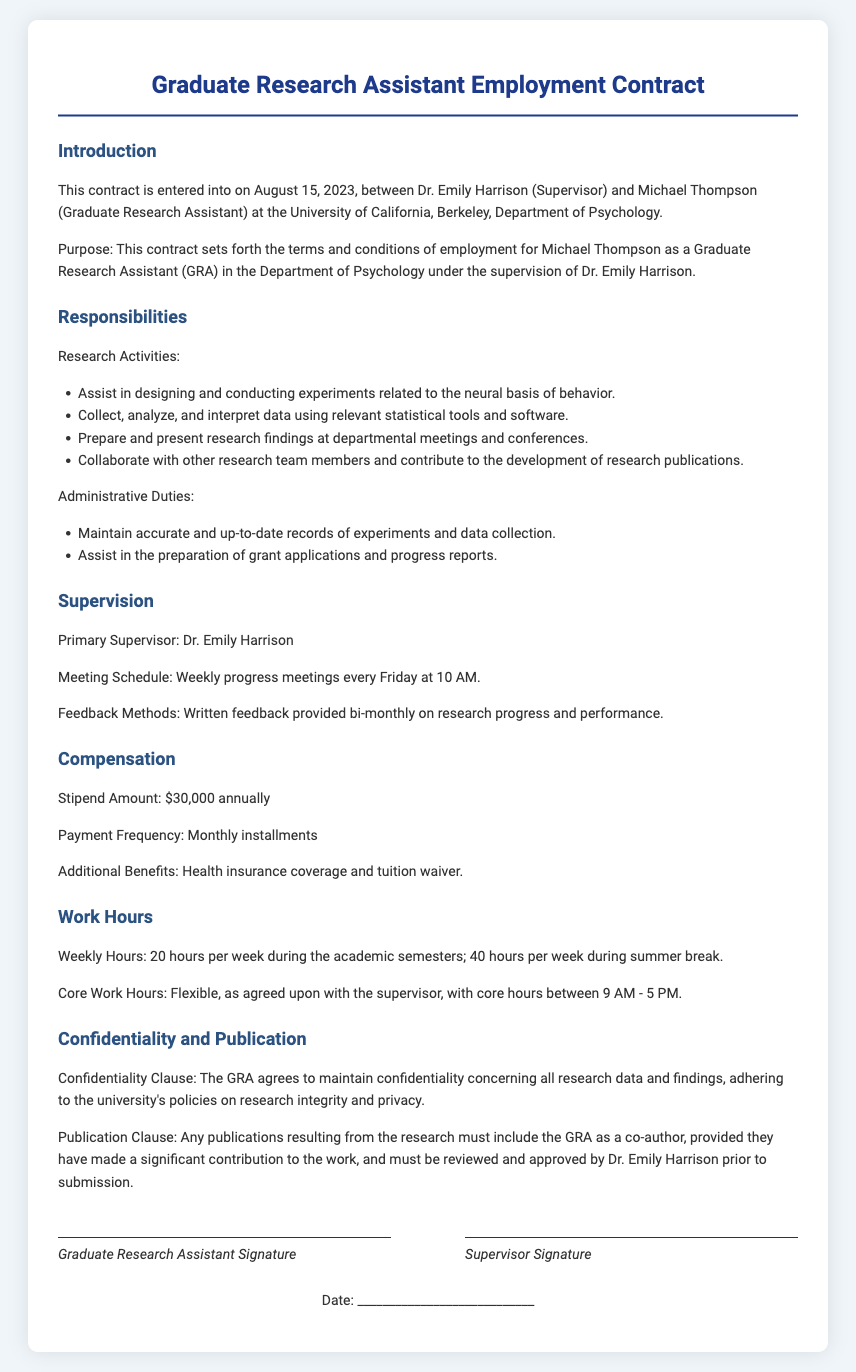What is the name of the primary supervisor? The document clearly states the primary supervisor's name, which is mentioned in the supervision section.
Answer: Dr. Emily Harrison When was the contract entered into? The date when the contract was established is specifically noted in the introduction section of the document.
Answer: August 15, 2023 What is the annual stipend amount? The compensation section provides the annual stipend amount for the Graduate Research Assistant.
Answer: $30,000 How many hours per week is the GRA expected to work during the summer break? The work hours section specifies the number of hours the Graduate Research Assistant is to work during the summer.
Answer: 40 hours per week What is the frequency of payments? In the compensation section, the document outlines the schedule on which payments will be made to the Graduate Research Assistant.
Answer: Monthly installments What is the purpose of the contract? The introduction section indicates the goal of the employment agreement as stated clearly in the document.
Answer: Employment terms What must be included in research publications? The publication clause details the requirements for authorship in research publications resulting from the work done by the GRA.
Answer: Co-author What is the core work hours range? The work hours section mentions the specific core hours during which work can be scheduled as agreed upon with the supervisor.
Answer: 9 AM - 5 PM 